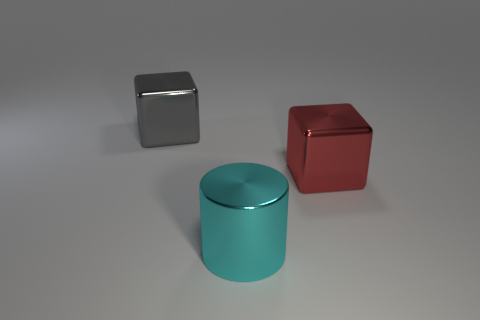Add 2 cyan shiny things. How many objects exist? 5 Subtract all blocks. How many objects are left? 1 Add 1 large rubber cylinders. How many large rubber cylinders exist? 1 Subtract 0 blue cylinders. How many objects are left? 3 Subtract all tiny matte cylinders. Subtract all large gray metal objects. How many objects are left? 2 Add 2 gray cubes. How many gray cubes are left? 3 